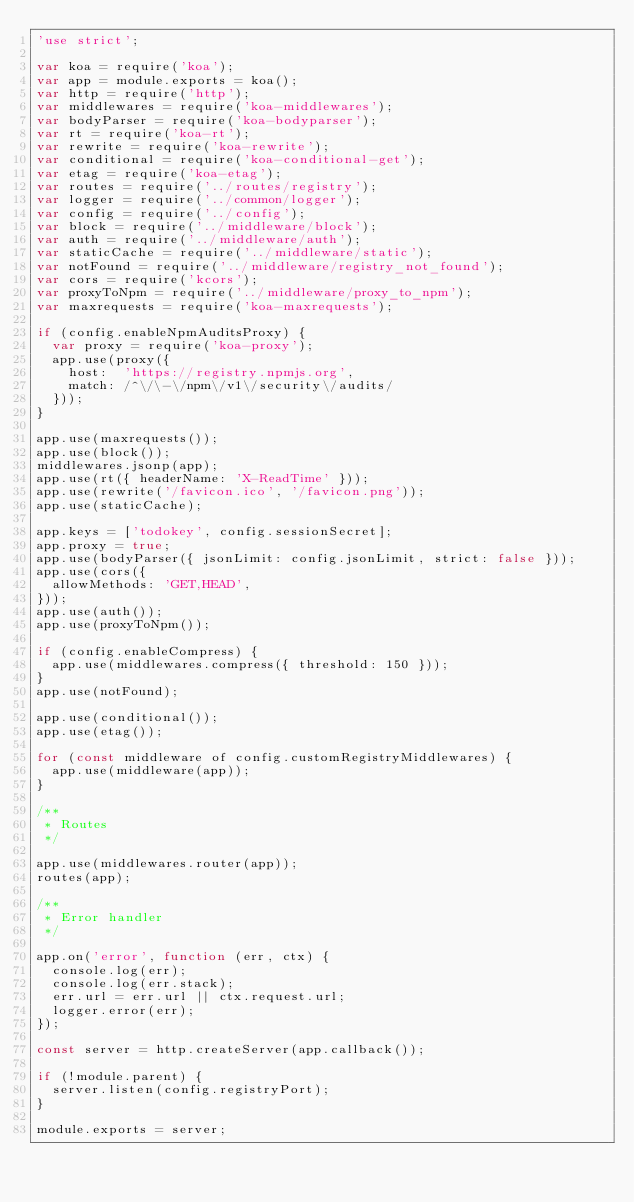Convert code to text. <code><loc_0><loc_0><loc_500><loc_500><_JavaScript_>'use strict';

var koa = require('koa');
var app = module.exports = koa();
var http = require('http');
var middlewares = require('koa-middlewares');
var bodyParser = require('koa-bodyparser');
var rt = require('koa-rt');
var rewrite = require('koa-rewrite');
var conditional = require('koa-conditional-get');
var etag = require('koa-etag');
var routes = require('../routes/registry');
var logger = require('../common/logger');
var config = require('../config');
var block = require('../middleware/block');
var auth = require('../middleware/auth');
var staticCache = require('../middleware/static');
var notFound = require('../middleware/registry_not_found');
var cors = require('kcors');
var proxyToNpm = require('../middleware/proxy_to_npm');
var maxrequests = require('koa-maxrequests');

if (config.enableNpmAuditsProxy) {
  var proxy = require('koa-proxy');
  app.use(proxy({
    host:  'https://registry.npmjs.org',
    match: /^\/\-\/npm\/v1\/security\/audits/
  }));
}

app.use(maxrequests());
app.use(block());
middlewares.jsonp(app);
app.use(rt({ headerName: 'X-ReadTime' }));
app.use(rewrite('/favicon.ico', '/favicon.png'));
app.use(staticCache);

app.keys = ['todokey', config.sessionSecret];
app.proxy = true;
app.use(bodyParser({ jsonLimit: config.jsonLimit, strict: false }));
app.use(cors({
  allowMethods: 'GET,HEAD',
}));
app.use(auth());
app.use(proxyToNpm());

if (config.enableCompress) {
  app.use(middlewares.compress({ threshold: 150 }));
}
app.use(notFound);

app.use(conditional());
app.use(etag());

for (const middleware of config.customRegistryMiddlewares) {
  app.use(middleware(app));
}

/**
 * Routes
 */

app.use(middlewares.router(app));
routes(app);

/**
 * Error handler
 */

app.on('error', function (err, ctx) {
  console.log(err);
  console.log(err.stack);
  err.url = err.url || ctx.request.url;
  logger.error(err);
});

const server = http.createServer(app.callback());

if (!module.parent) {
  server.listen(config.registryPort);
}

module.exports = server;
</code> 